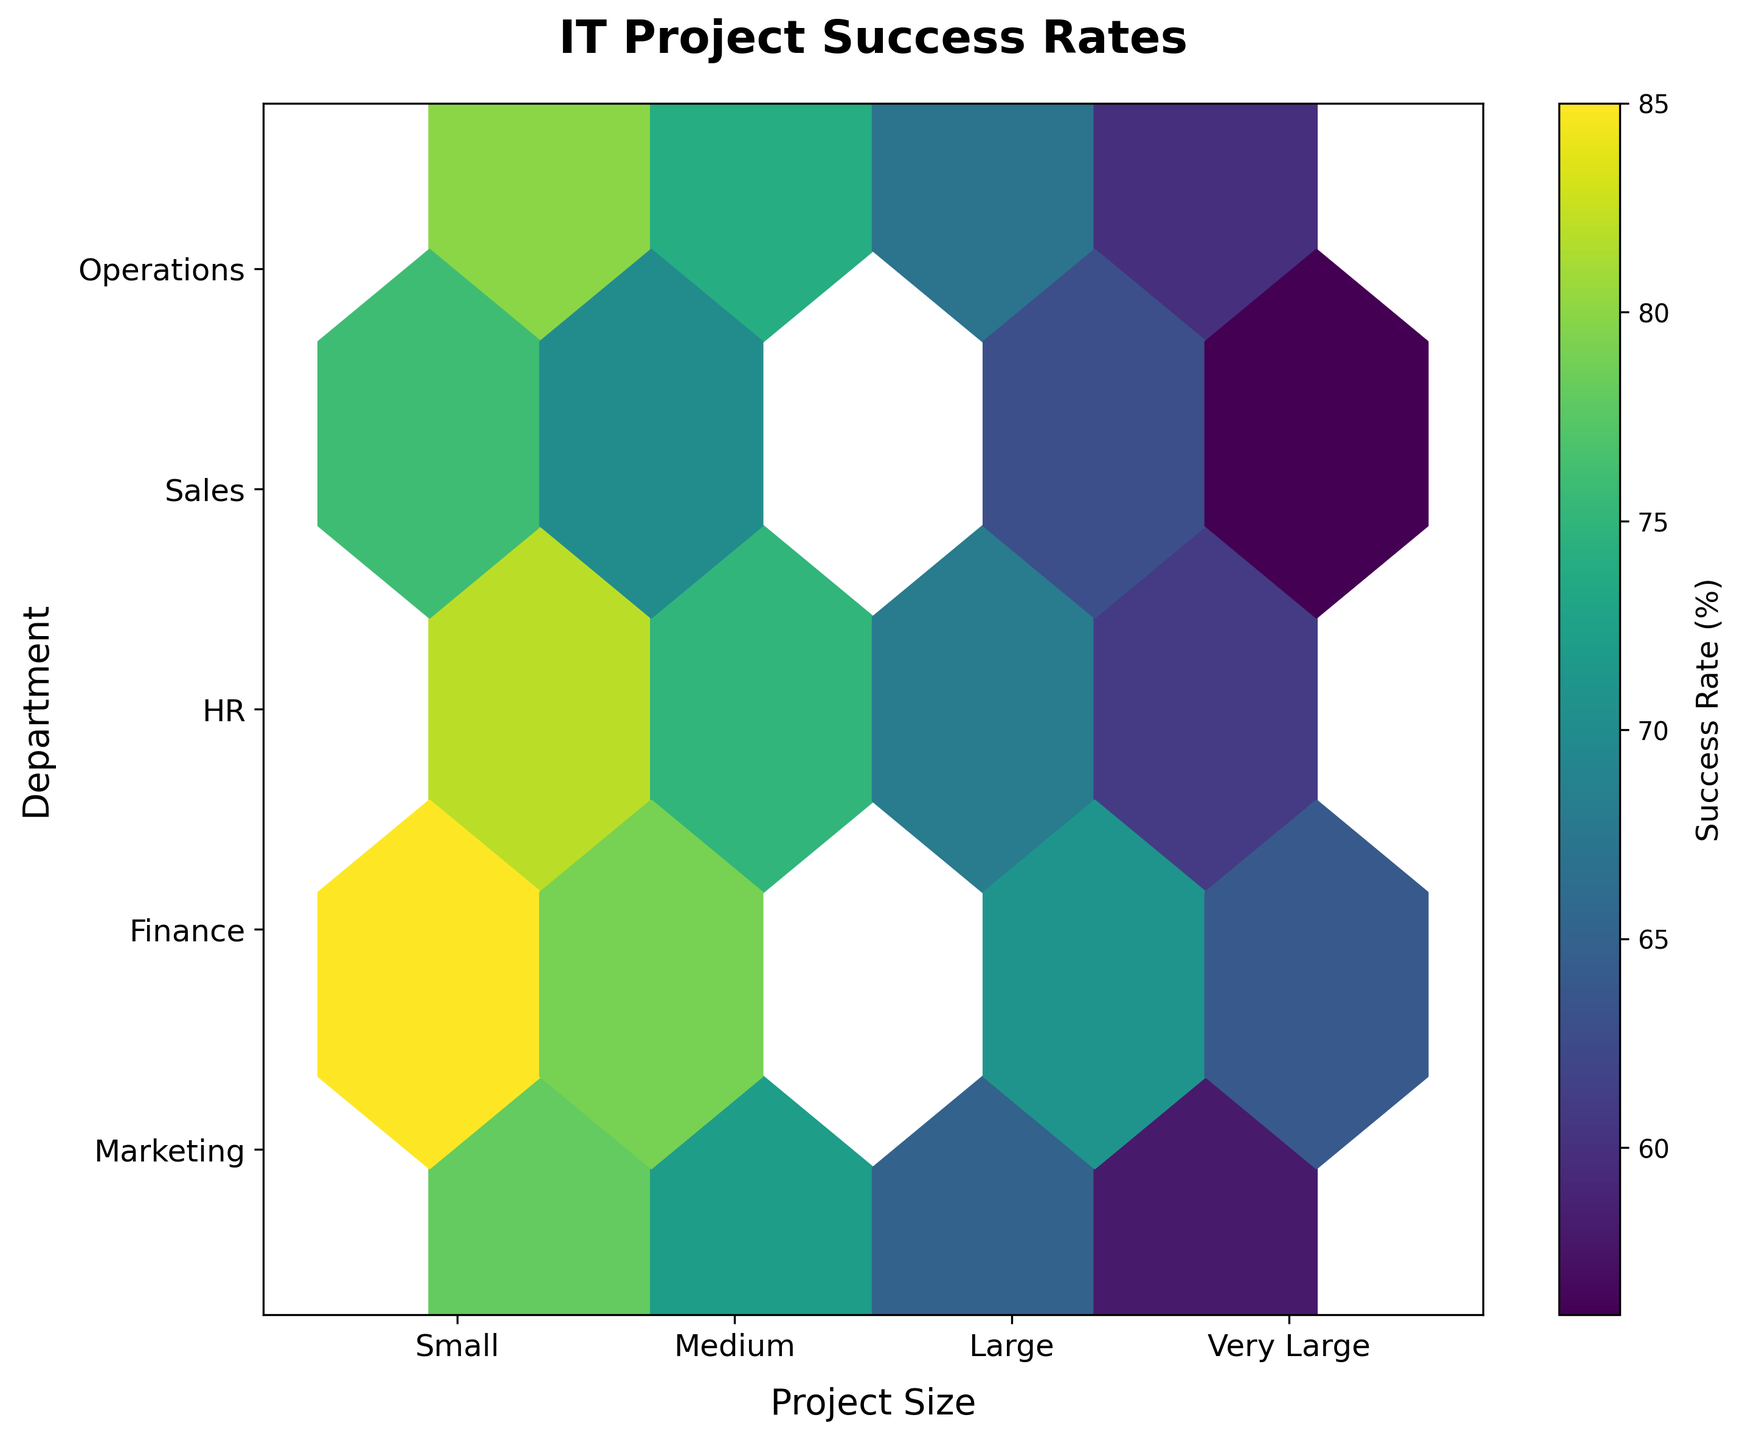What's the title of the figure? The title is usually provided at the top of the figure. In this case, it says 'IT Project Success Rates'.
Answer: IT Project Success Rates What are the axes labeled and what do they represent? The x-axis is labeled 'Project Size' which categorizes project sizes as Small, Medium, Large, and Very Large. The y-axis is labeled 'Department' which categorizes the departments into Marketing, Finance, HR, Sales, and Operations.
Answer: Project Size and Department Which project size shows the highest success rates overall? By looking at the color intensity in the hexbin plot, which ranges from darker (higher success rates) to lighter (lower success rates), the 'Small' project size contains the darkest hexagons indicating highest success rates.
Answer: Small Which department has the lowest success rates for 'Very Large' projects? In the 'Very Large' category on the x-axis, the colors for each department's hexagons can be compared. The 'Sales' department has the lightest color indicating the lowest success rates.
Answer: Sales What's the success rate range for the 'Finance' department across all project sizes? To determine the range, identify the lowest and highest values of success rates by observing the color gradients for the Finance department across all project sizes. The success rate in 'Finance' ranges from the lowest around 64% (Very Large) to the highest around 85% (Small).
Answer: 64% to 85% Which project size has the most consistent success rates across all departments? Consistency can be judged by how steady the color gradient is across the departments for each project size. 'Medium' projects show the most consistent success rates with colors not varying dramatically across departments.
Answer: Medium How do success rates of 'Sales' department in 'Small' projects compare to 'HR' department in 'Medium' projects? To compare these, look at the color intensity of 'Sales' in 'Small' projects and 'HR' in 'Medium' projects. The 'Sales' department in 'Small' projects has slightly darker colors, indicating higher success rates than the 'HR' department in 'Medium' projects.
Answer: Sales in Small is higher Which department shows the largest decrease in success rates when moving from 'Small' to 'Very Large' projects? To find this, compare the color intensity of each department from 'Small' to 'Very Large' project sizes. The 'Marketing' department shows a significant decrease in color intensity, indicating the largest drop in success rates.
Answer: Marketing Are there any departments that have uniform success rates for all project sizes? Uniform success rates would show no drastic changes in color intensity across project sizes for a specific department. No department displays completely uniform success rates across all project sizes, as indicated by varying color intensities.
Answer: No What can be inferred about the 'Operations' department's performance as project size increases? By observing the gradient change in color for the 'Operations' department from 'Small' to 'Very Large', it can be inferred that the success rates decline as project size increases, with darker colors in 'Small' decreasing to lighter colors in 'Very Large'.
Answer: Declines 